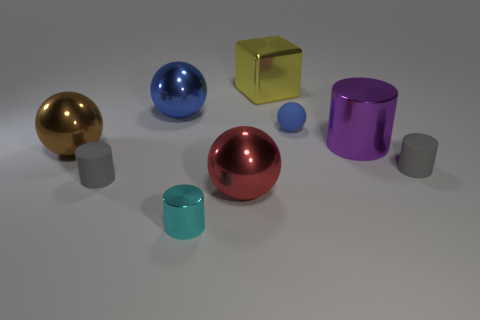Is the number of yellow things that are on the right side of the big cylinder the same as the number of cyan metallic things that are on the right side of the brown metallic object?
Ensure brevity in your answer.  No. What is the shape of the big object that is the same color as the small ball?
Offer a terse response. Sphere. What is the material of the gray object that is right of the blue matte ball?
Offer a terse response. Rubber. Is the size of the yellow thing the same as the blue metal object?
Give a very brief answer. Yes. Is the number of balls in front of the purple object greater than the number of tiny yellow rubber objects?
Provide a short and direct response. Yes. There is a cyan object that is the same material as the brown thing; what is its size?
Keep it short and to the point. Small. There is a yellow metallic block; are there any cyan cylinders in front of it?
Provide a short and direct response. Yes. Is the shape of the large brown metallic object the same as the blue matte thing?
Provide a short and direct response. Yes. There is a metallic cylinder that is to the left of the big sphere that is in front of the tiny gray matte cylinder right of the cyan object; what is its size?
Your response must be concise. Small. What is the tiny blue thing made of?
Offer a terse response. Rubber. 